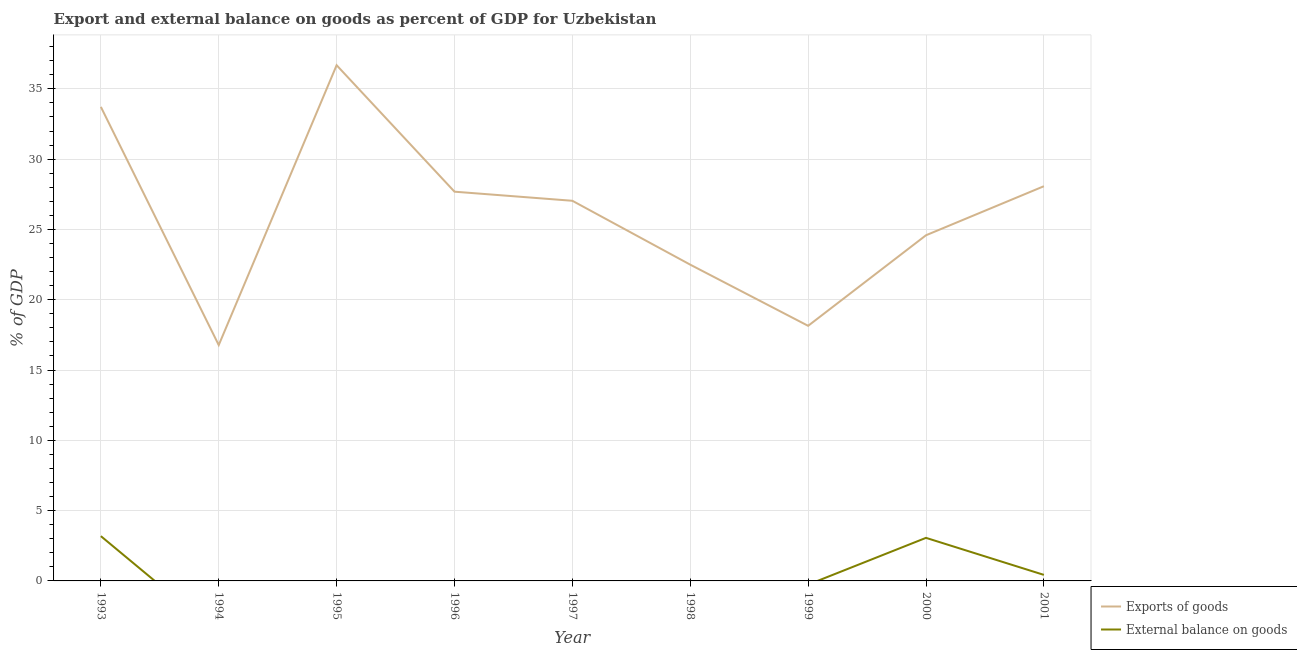Across all years, what is the maximum export of goods as percentage of gdp?
Ensure brevity in your answer.  36.68. Across all years, what is the minimum export of goods as percentage of gdp?
Keep it short and to the point. 16.78. What is the total export of goods as percentage of gdp in the graph?
Give a very brief answer. 235.21. What is the difference between the export of goods as percentage of gdp in 2000 and that in 2001?
Offer a terse response. -3.49. What is the difference between the export of goods as percentage of gdp in 1999 and the external balance on goods as percentage of gdp in 1996?
Your answer should be compact. 18.15. What is the average export of goods as percentage of gdp per year?
Your answer should be compact. 26.13. In the year 2000, what is the difference between the export of goods as percentage of gdp and external balance on goods as percentage of gdp?
Your answer should be compact. 21.52. What is the ratio of the export of goods as percentage of gdp in 1993 to that in 1998?
Your response must be concise. 1.5. Is the export of goods as percentage of gdp in 1997 less than that in 2000?
Your answer should be compact. No. What is the difference between the highest and the second highest export of goods as percentage of gdp?
Your answer should be very brief. 2.96. What is the difference between the highest and the lowest export of goods as percentage of gdp?
Your answer should be very brief. 19.91. How many years are there in the graph?
Provide a short and direct response. 9. What is the difference between two consecutive major ticks on the Y-axis?
Your response must be concise. 5. Does the graph contain any zero values?
Offer a very short reply. Yes. Does the graph contain grids?
Give a very brief answer. Yes. How are the legend labels stacked?
Offer a very short reply. Vertical. What is the title of the graph?
Ensure brevity in your answer.  Export and external balance on goods as percent of GDP for Uzbekistan. Does "Investment in Transport" appear as one of the legend labels in the graph?
Give a very brief answer. No. What is the label or title of the Y-axis?
Ensure brevity in your answer.  % of GDP. What is the % of GDP of Exports of goods in 1993?
Provide a succinct answer. 33.72. What is the % of GDP of External balance on goods in 1993?
Give a very brief answer. 3.19. What is the % of GDP of Exports of goods in 1994?
Provide a succinct answer. 16.78. What is the % of GDP of Exports of goods in 1995?
Provide a succinct answer. 36.68. What is the % of GDP in Exports of goods in 1996?
Your answer should be compact. 27.69. What is the % of GDP in External balance on goods in 1996?
Offer a very short reply. 0. What is the % of GDP of Exports of goods in 1997?
Make the answer very short. 27.04. What is the % of GDP of Exports of goods in 1998?
Provide a succinct answer. 22.5. What is the % of GDP in External balance on goods in 1998?
Ensure brevity in your answer.  0. What is the % of GDP in Exports of goods in 1999?
Keep it short and to the point. 18.15. What is the % of GDP in Exports of goods in 2000?
Offer a very short reply. 24.59. What is the % of GDP of External balance on goods in 2000?
Make the answer very short. 3.06. What is the % of GDP of Exports of goods in 2001?
Give a very brief answer. 28.08. What is the % of GDP in External balance on goods in 2001?
Ensure brevity in your answer.  0.43. Across all years, what is the maximum % of GDP of Exports of goods?
Make the answer very short. 36.68. Across all years, what is the maximum % of GDP of External balance on goods?
Provide a short and direct response. 3.19. Across all years, what is the minimum % of GDP in Exports of goods?
Keep it short and to the point. 16.78. What is the total % of GDP in Exports of goods in the graph?
Provide a short and direct response. 235.21. What is the total % of GDP of External balance on goods in the graph?
Give a very brief answer. 6.68. What is the difference between the % of GDP in Exports of goods in 1993 and that in 1994?
Your answer should be compact. 16.94. What is the difference between the % of GDP in Exports of goods in 1993 and that in 1995?
Provide a succinct answer. -2.96. What is the difference between the % of GDP of Exports of goods in 1993 and that in 1996?
Your response must be concise. 6.03. What is the difference between the % of GDP of Exports of goods in 1993 and that in 1997?
Give a very brief answer. 6.68. What is the difference between the % of GDP in Exports of goods in 1993 and that in 1998?
Your response must be concise. 11.22. What is the difference between the % of GDP in Exports of goods in 1993 and that in 1999?
Your response must be concise. 15.57. What is the difference between the % of GDP of Exports of goods in 1993 and that in 2000?
Make the answer very short. 9.13. What is the difference between the % of GDP in External balance on goods in 1993 and that in 2000?
Your response must be concise. 0.12. What is the difference between the % of GDP in Exports of goods in 1993 and that in 2001?
Your response must be concise. 5.64. What is the difference between the % of GDP in External balance on goods in 1993 and that in 2001?
Make the answer very short. 2.76. What is the difference between the % of GDP of Exports of goods in 1994 and that in 1995?
Provide a short and direct response. -19.91. What is the difference between the % of GDP in Exports of goods in 1994 and that in 1996?
Your response must be concise. -10.91. What is the difference between the % of GDP in Exports of goods in 1994 and that in 1997?
Provide a succinct answer. -10.26. What is the difference between the % of GDP in Exports of goods in 1994 and that in 1998?
Your response must be concise. -5.72. What is the difference between the % of GDP of Exports of goods in 1994 and that in 1999?
Ensure brevity in your answer.  -1.37. What is the difference between the % of GDP of Exports of goods in 1994 and that in 2000?
Provide a short and direct response. -7.81. What is the difference between the % of GDP of Exports of goods in 1995 and that in 1996?
Your answer should be very brief. 9. What is the difference between the % of GDP in Exports of goods in 1995 and that in 1997?
Provide a short and direct response. 9.64. What is the difference between the % of GDP in Exports of goods in 1995 and that in 1998?
Provide a succinct answer. 14.19. What is the difference between the % of GDP in Exports of goods in 1995 and that in 1999?
Your response must be concise. 18.54. What is the difference between the % of GDP of Exports of goods in 1995 and that in 2000?
Keep it short and to the point. 12.1. What is the difference between the % of GDP in Exports of goods in 1995 and that in 2001?
Give a very brief answer. 8.61. What is the difference between the % of GDP in Exports of goods in 1996 and that in 1997?
Offer a terse response. 0.65. What is the difference between the % of GDP in Exports of goods in 1996 and that in 1998?
Give a very brief answer. 5.19. What is the difference between the % of GDP of Exports of goods in 1996 and that in 1999?
Your response must be concise. 9.54. What is the difference between the % of GDP in Exports of goods in 1996 and that in 2000?
Make the answer very short. 3.1. What is the difference between the % of GDP of Exports of goods in 1996 and that in 2001?
Your answer should be very brief. -0.39. What is the difference between the % of GDP of Exports of goods in 1997 and that in 1998?
Your answer should be very brief. 4.54. What is the difference between the % of GDP of Exports of goods in 1997 and that in 1999?
Keep it short and to the point. 8.89. What is the difference between the % of GDP of Exports of goods in 1997 and that in 2000?
Offer a terse response. 2.45. What is the difference between the % of GDP in Exports of goods in 1997 and that in 2001?
Your answer should be very brief. -1.04. What is the difference between the % of GDP of Exports of goods in 1998 and that in 1999?
Give a very brief answer. 4.35. What is the difference between the % of GDP of Exports of goods in 1998 and that in 2000?
Ensure brevity in your answer.  -2.09. What is the difference between the % of GDP in Exports of goods in 1998 and that in 2001?
Your response must be concise. -5.58. What is the difference between the % of GDP in Exports of goods in 1999 and that in 2000?
Make the answer very short. -6.44. What is the difference between the % of GDP in Exports of goods in 1999 and that in 2001?
Your response must be concise. -9.93. What is the difference between the % of GDP in Exports of goods in 2000 and that in 2001?
Your answer should be compact. -3.49. What is the difference between the % of GDP of External balance on goods in 2000 and that in 2001?
Provide a short and direct response. 2.63. What is the difference between the % of GDP in Exports of goods in 1993 and the % of GDP in External balance on goods in 2000?
Make the answer very short. 30.66. What is the difference between the % of GDP in Exports of goods in 1993 and the % of GDP in External balance on goods in 2001?
Your answer should be very brief. 33.29. What is the difference between the % of GDP in Exports of goods in 1994 and the % of GDP in External balance on goods in 2000?
Your answer should be very brief. 13.71. What is the difference between the % of GDP of Exports of goods in 1994 and the % of GDP of External balance on goods in 2001?
Provide a succinct answer. 16.35. What is the difference between the % of GDP in Exports of goods in 1995 and the % of GDP in External balance on goods in 2000?
Provide a succinct answer. 33.62. What is the difference between the % of GDP in Exports of goods in 1995 and the % of GDP in External balance on goods in 2001?
Give a very brief answer. 36.25. What is the difference between the % of GDP of Exports of goods in 1996 and the % of GDP of External balance on goods in 2000?
Give a very brief answer. 24.62. What is the difference between the % of GDP in Exports of goods in 1996 and the % of GDP in External balance on goods in 2001?
Keep it short and to the point. 27.26. What is the difference between the % of GDP in Exports of goods in 1997 and the % of GDP in External balance on goods in 2000?
Your response must be concise. 23.98. What is the difference between the % of GDP of Exports of goods in 1997 and the % of GDP of External balance on goods in 2001?
Make the answer very short. 26.61. What is the difference between the % of GDP of Exports of goods in 1998 and the % of GDP of External balance on goods in 2000?
Your response must be concise. 19.43. What is the difference between the % of GDP of Exports of goods in 1998 and the % of GDP of External balance on goods in 2001?
Provide a succinct answer. 22.07. What is the difference between the % of GDP in Exports of goods in 1999 and the % of GDP in External balance on goods in 2000?
Your response must be concise. 15.08. What is the difference between the % of GDP in Exports of goods in 1999 and the % of GDP in External balance on goods in 2001?
Offer a very short reply. 17.72. What is the difference between the % of GDP of Exports of goods in 2000 and the % of GDP of External balance on goods in 2001?
Make the answer very short. 24.16. What is the average % of GDP of Exports of goods per year?
Offer a terse response. 26.13. What is the average % of GDP of External balance on goods per year?
Your response must be concise. 0.74. In the year 1993, what is the difference between the % of GDP of Exports of goods and % of GDP of External balance on goods?
Keep it short and to the point. 30.53. In the year 2000, what is the difference between the % of GDP of Exports of goods and % of GDP of External balance on goods?
Your answer should be very brief. 21.52. In the year 2001, what is the difference between the % of GDP of Exports of goods and % of GDP of External balance on goods?
Keep it short and to the point. 27.65. What is the ratio of the % of GDP of Exports of goods in 1993 to that in 1994?
Offer a terse response. 2.01. What is the ratio of the % of GDP in Exports of goods in 1993 to that in 1995?
Make the answer very short. 0.92. What is the ratio of the % of GDP in Exports of goods in 1993 to that in 1996?
Your answer should be very brief. 1.22. What is the ratio of the % of GDP in Exports of goods in 1993 to that in 1997?
Provide a short and direct response. 1.25. What is the ratio of the % of GDP in Exports of goods in 1993 to that in 1998?
Your response must be concise. 1.5. What is the ratio of the % of GDP of Exports of goods in 1993 to that in 1999?
Offer a terse response. 1.86. What is the ratio of the % of GDP of Exports of goods in 1993 to that in 2000?
Your answer should be compact. 1.37. What is the ratio of the % of GDP of External balance on goods in 1993 to that in 2000?
Give a very brief answer. 1.04. What is the ratio of the % of GDP of Exports of goods in 1993 to that in 2001?
Keep it short and to the point. 1.2. What is the ratio of the % of GDP of External balance on goods in 1993 to that in 2001?
Offer a terse response. 7.41. What is the ratio of the % of GDP in Exports of goods in 1994 to that in 1995?
Offer a terse response. 0.46. What is the ratio of the % of GDP in Exports of goods in 1994 to that in 1996?
Ensure brevity in your answer.  0.61. What is the ratio of the % of GDP of Exports of goods in 1994 to that in 1997?
Give a very brief answer. 0.62. What is the ratio of the % of GDP in Exports of goods in 1994 to that in 1998?
Give a very brief answer. 0.75. What is the ratio of the % of GDP of Exports of goods in 1994 to that in 1999?
Offer a very short reply. 0.92. What is the ratio of the % of GDP in Exports of goods in 1994 to that in 2000?
Your response must be concise. 0.68. What is the ratio of the % of GDP of Exports of goods in 1994 to that in 2001?
Your answer should be compact. 0.6. What is the ratio of the % of GDP in Exports of goods in 1995 to that in 1996?
Your answer should be compact. 1.32. What is the ratio of the % of GDP of Exports of goods in 1995 to that in 1997?
Your answer should be very brief. 1.36. What is the ratio of the % of GDP of Exports of goods in 1995 to that in 1998?
Make the answer very short. 1.63. What is the ratio of the % of GDP of Exports of goods in 1995 to that in 1999?
Give a very brief answer. 2.02. What is the ratio of the % of GDP in Exports of goods in 1995 to that in 2000?
Your answer should be compact. 1.49. What is the ratio of the % of GDP in Exports of goods in 1995 to that in 2001?
Keep it short and to the point. 1.31. What is the ratio of the % of GDP in Exports of goods in 1996 to that in 1997?
Provide a short and direct response. 1.02. What is the ratio of the % of GDP in Exports of goods in 1996 to that in 1998?
Provide a succinct answer. 1.23. What is the ratio of the % of GDP of Exports of goods in 1996 to that in 1999?
Your answer should be very brief. 1.53. What is the ratio of the % of GDP of Exports of goods in 1996 to that in 2000?
Offer a terse response. 1.13. What is the ratio of the % of GDP of Exports of goods in 1996 to that in 2001?
Your response must be concise. 0.99. What is the ratio of the % of GDP of Exports of goods in 1997 to that in 1998?
Keep it short and to the point. 1.2. What is the ratio of the % of GDP in Exports of goods in 1997 to that in 1999?
Give a very brief answer. 1.49. What is the ratio of the % of GDP in Exports of goods in 1997 to that in 2000?
Provide a short and direct response. 1.1. What is the ratio of the % of GDP of Exports of goods in 1997 to that in 2001?
Provide a succinct answer. 0.96. What is the ratio of the % of GDP of Exports of goods in 1998 to that in 1999?
Offer a terse response. 1.24. What is the ratio of the % of GDP in Exports of goods in 1998 to that in 2000?
Give a very brief answer. 0.91. What is the ratio of the % of GDP in Exports of goods in 1998 to that in 2001?
Provide a short and direct response. 0.8. What is the ratio of the % of GDP of Exports of goods in 1999 to that in 2000?
Keep it short and to the point. 0.74. What is the ratio of the % of GDP in Exports of goods in 1999 to that in 2001?
Keep it short and to the point. 0.65. What is the ratio of the % of GDP of Exports of goods in 2000 to that in 2001?
Provide a short and direct response. 0.88. What is the ratio of the % of GDP in External balance on goods in 2000 to that in 2001?
Ensure brevity in your answer.  7.13. What is the difference between the highest and the second highest % of GDP of Exports of goods?
Keep it short and to the point. 2.96. What is the difference between the highest and the second highest % of GDP of External balance on goods?
Make the answer very short. 0.12. What is the difference between the highest and the lowest % of GDP in Exports of goods?
Ensure brevity in your answer.  19.91. What is the difference between the highest and the lowest % of GDP in External balance on goods?
Provide a succinct answer. 3.19. 